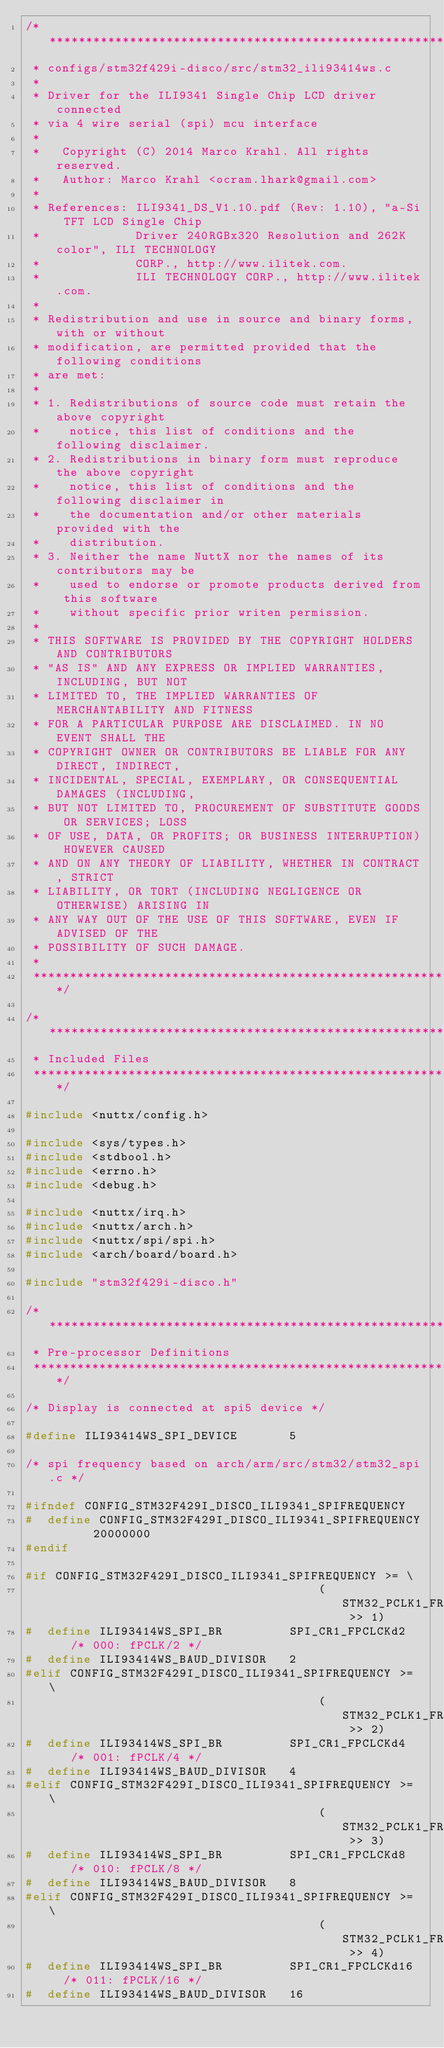<code> <loc_0><loc_0><loc_500><loc_500><_C_>/****************************************************************************
 * configs/stm32f429i-disco/src/stm32_ili93414ws.c
 *
 * Driver for the ILI9341 Single Chip LCD driver connected
 * via 4 wire serial (spi) mcu interface
 *
 *   Copyright (C) 2014 Marco Krahl. All rights reserved.
 *   Author: Marco Krahl <ocram.lhark@gmail.com>
 *
 * References: ILI9341_DS_V1.10.pdf (Rev: 1.10), "a-Si TFT LCD Single Chip
 *             Driver 240RGBx320 Resolution and 262K color", ILI TECHNOLOGY
 *             CORP., http://www.ilitek.com.
 *             ILI TECHNOLOGY CORP., http://www.ilitek.com.
 *
 * Redistribution and use in source and binary forms, with or without
 * modification, are permitted provided that the following conditions
 * are met:
 *
 * 1. Redistributions of source code must retain the above copyright
 *    notice, this list of conditions and the following disclaimer.
 * 2. Redistributions in binary form must reproduce the above copyright
 *    notice, this list of conditions and the following disclaimer in
 *    the documentation and/or other materials provided with the
 *    distribution.
 * 3. Neither the name NuttX nor the names of its contributors may be
 *    used to endorse or promote products derived from this software
 *    without specific prior writen permission.
 *
 * THIS SOFTWARE IS PROVIDED BY THE COPYRIGHT HOLDERS AND CONTRIBUTORS
 * "AS IS" AND ANY EXPRESS OR IMPLIED WARRANTIES, INCLUDING, BUT NOT
 * LIMITED TO, THE IMPLIED WARRANTIES OF MERCHANTABILITY AND FITNESS
 * FOR A PARTICULAR PURPOSE ARE DISCLAIMED. IN NO EVENT SHALL THE
 * COPYRIGHT OWNER OR CONTRIBUTORS BE LIABLE FOR ANY DIRECT, INDIRECT,
 * INCIDENTAL, SPECIAL, EXEMPLARY, OR CONSEQUENTIAL DAMAGES (INCLUDING,
 * BUT NOT LIMITED TO, PROCUREMENT OF SUBSTITUTE GOODS OR SERVICES; LOSS
 * OF USE, DATA, OR PROFITS; OR BUSINESS INTERRUPTION) HOWEVER CAUSED
 * AND ON ANY THEORY OF LIABILITY, WHETHER IN CONTRACT, STRICT
 * LIABILITY, OR TORT (INCLUDING NEGLIGENCE OR OTHERWISE) ARISING IN
 * ANY WAY OUT OF THE USE OF THIS SOFTWARE, EVEN IF ADVISED OF THE
 * POSSIBILITY OF SUCH DAMAGE.
 *
 ****************************************************************************/

/****************************************************************************
 * Included Files
 ****************************************************************************/

#include <nuttx/config.h>

#include <sys/types.h>
#include <stdbool.h>
#include <errno.h>
#include <debug.h>

#include <nuttx/irq.h>
#include <nuttx/arch.h>
#include <nuttx/spi/spi.h>
#include <arch/board/board.h>

#include "stm32f429i-disco.h"

/****************************************************************************
 * Pre-processor Definitions
 ****************************************************************************/

/* Display is connected at spi5 device */

#define ILI93414WS_SPI_DEVICE       5

/* spi frequency based on arch/arm/src/stm32/stm32_spi.c */

#ifndef CONFIG_STM32F429I_DISCO_ILI9341_SPIFREQUENCY
#  define CONFIG_STM32F429I_DISCO_ILI9341_SPIFREQUENCY      20000000
#endif

#if CONFIG_STM32F429I_DISCO_ILI9341_SPIFREQUENCY >= \
                                        (STM32_PCLK1_FREQUENCY >> 1)
#  define ILI93414WS_SPI_BR         SPI_CR1_FPCLCKd2    /* 000: fPCLK/2 */
#  define ILI93414WS_BAUD_DIVISOR   2
#elif CONFIG_STM32F429I_DISCO_ILI9341_SPIFREQUENCY >= \
                                        (STM32_PCLK1_FREQUENCY >> 2)
#  define ILI93414WS_SPI_BR         SPI_CR1_FPCLCKd4    /* 001: fPCLK/4 */
#  define ILI93414WS_BAUD_DIVISOR   4
#elif CONFIG_STM32F429I_DISCO_ILI9341_SPIFREQUENCY >= \
                                        (STM32_PCLK1_FREQUENCY >> 3)
#  define ILI93414WS_SPI_BR         SPI_CR1_FPCLCKd8    /* 010: fPCLK/8 */
#  define ILI93414WS_BAUD_DIVISOR   8
#elif CONFIG_STM32F429I_DISCO_ILI9341_SPIFREQUENCY >= \
                                        (STM32_PCLK1_FREQUENCY >> 4)
#  define ILI93414WS_SPI_BR         SPI_CR1_FPCLCKd16   /* 011: fPCLK/16 */
#  define ILI93414WS_BAUD_DIVISOR   16</code> 